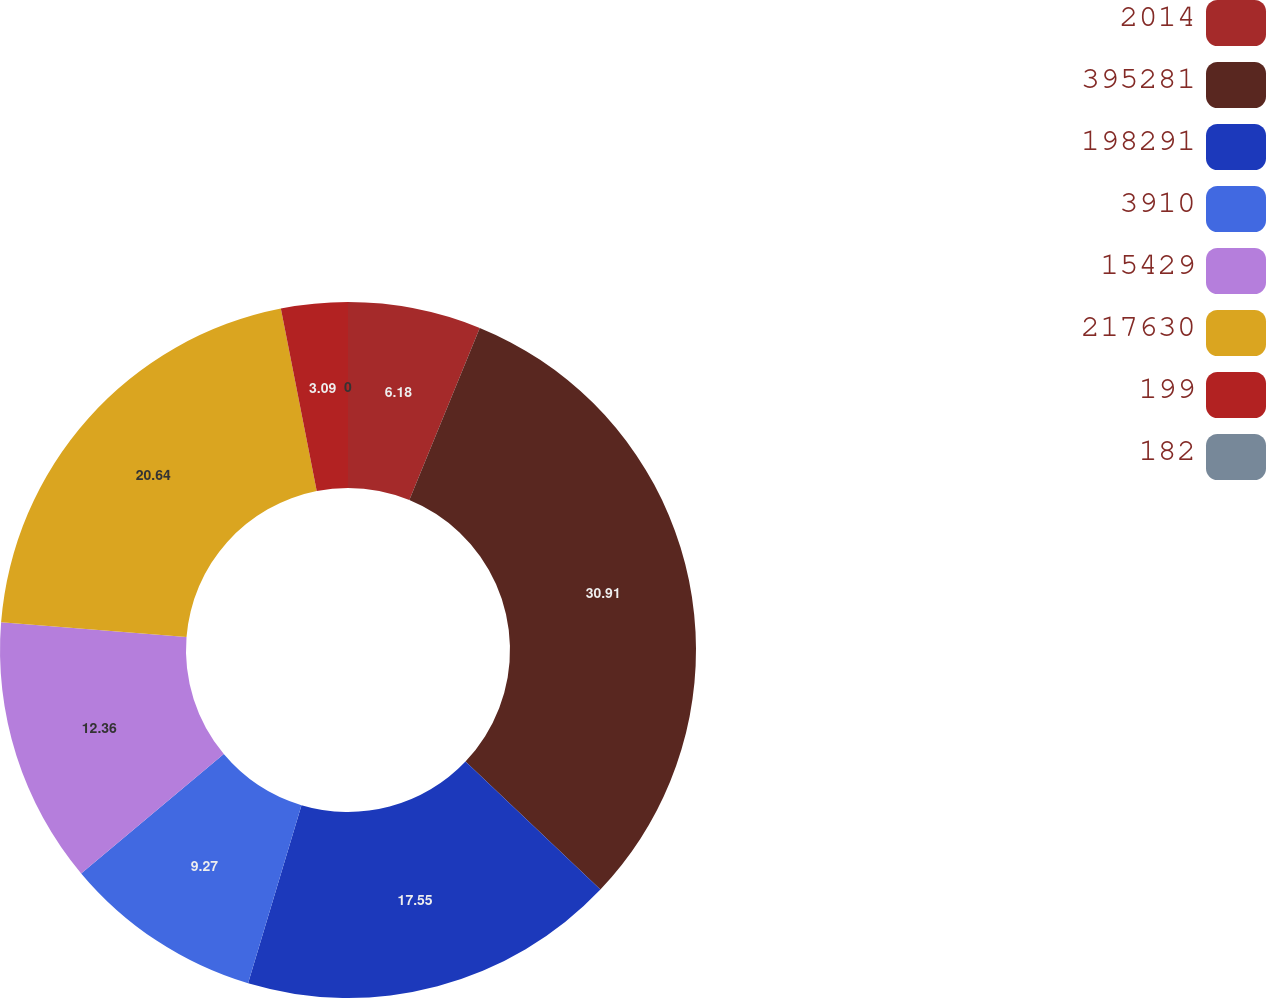Convert chart to OTSL. <chart><loc_0><loc_0><loc_500><loc_500><pie_chart><fcel>2014<fcel>395281<fcel>198291<fcel>3910<fcel>15429<fcel>217630<fcel>199<fcel>182<nl><fcel>6.18%<fcel>30.9%<fcel>17.55%<fcel>9.27%<fcel>12.36%<fcel>20.64%<fcel>3.09%<fcel>0.0%<nl></chart> 